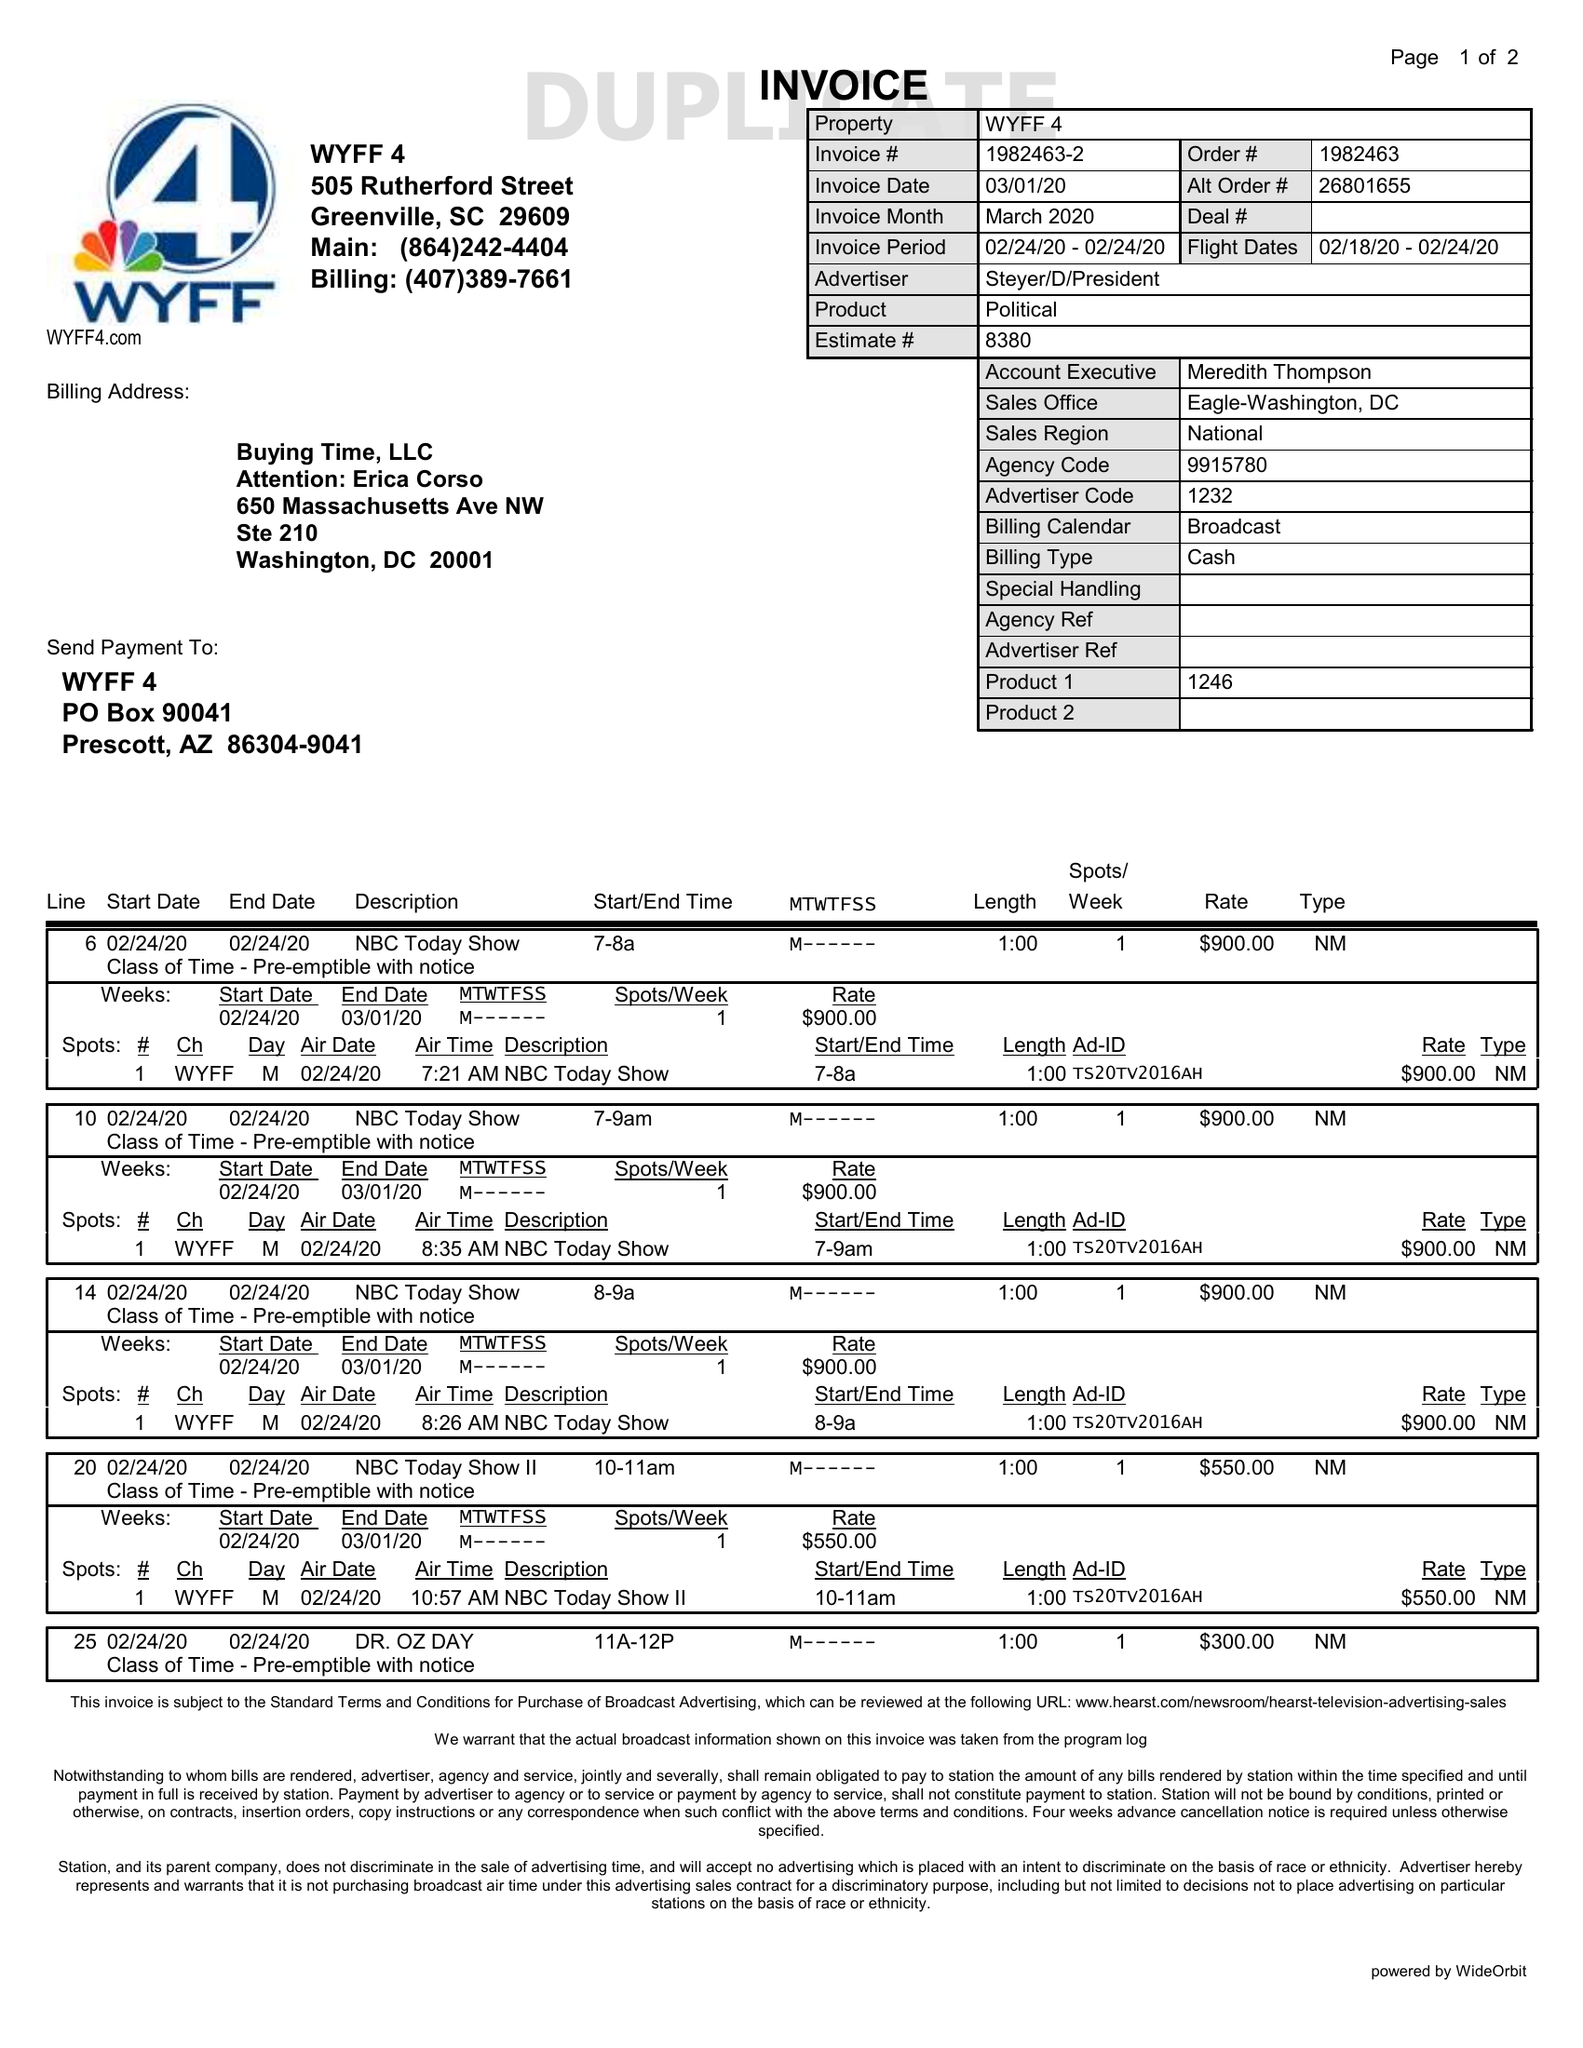What is the value for the flight_to?
Answer the question using a single word or phrase. 02/24/20 